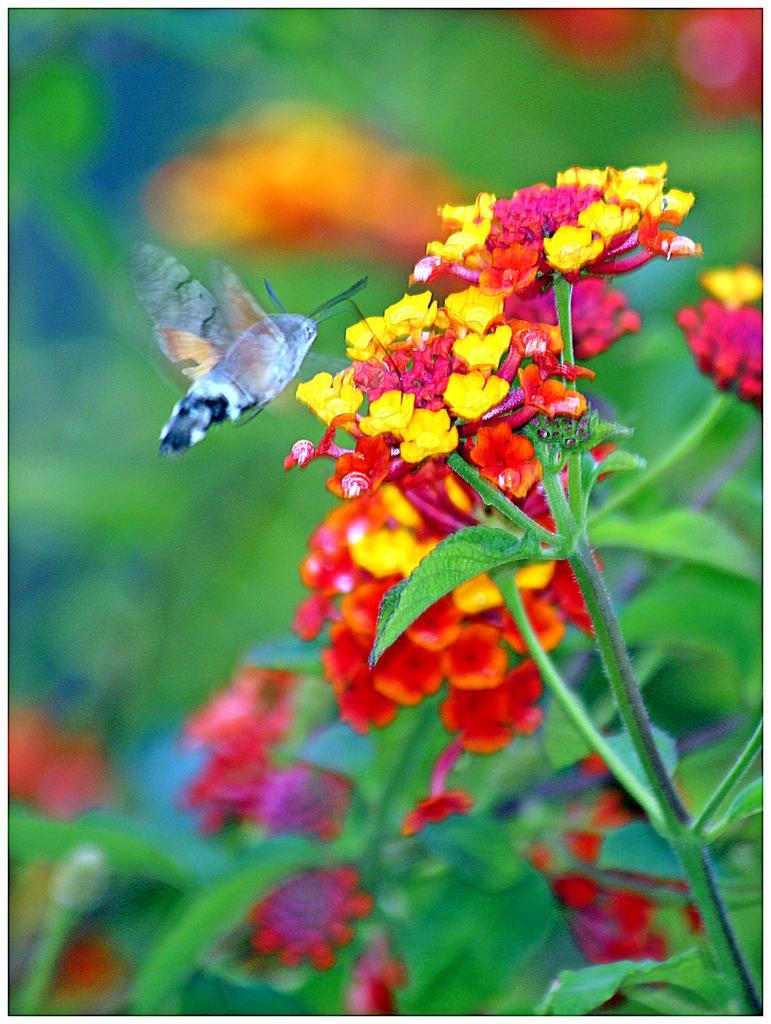Can you describe this image briefly? In this picture there is a butterfly which is flying near to the flowers. In the right I can see the yellow and red flowers on the plant. At the bottom I can see the leaves. 